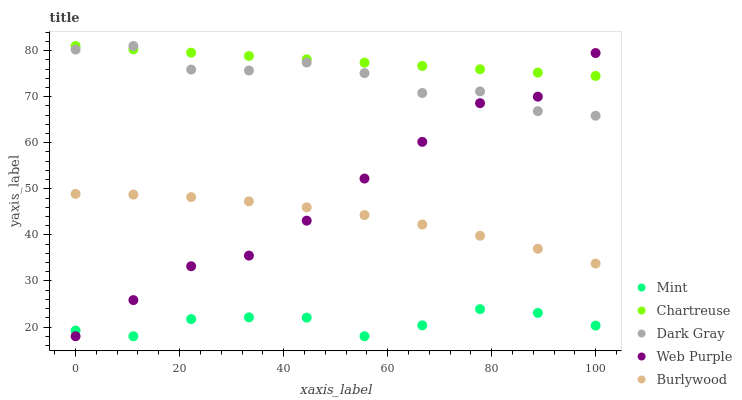Does Mint have the minimum area under the curve?
Answer yes or no. Yes. Does Chartreuse have the maximum area under the curve?
Answer yes or no. Yes. Does Burlywood have the minimum area under the curve?
Answer yes or no. No. Does Burlywood have the maximum area under the curve?
Answer yes or no. No. Is Chartreuse the smoothest?
Answer yes or no. Yes. Is Dark Gray the roughest?
Answer yes or no. Yes. Is Burlywood the smoothest?
Answer yes or no. No. Is Burlywood the roughest?
Answer yes or no. No. Does Mint have the lowest value?
Answer yes or no. Yes. Does Burlywood have the lowest value?
Answer yes or no. No. Does Chartreuse have the highest value?
Answer yes or no. Yes. Does Burlywood have the highest value?
Answer yes or no. No. Is Burlywood less than Dark Gray?
Answer yes or no. Yes. Is Dark Gray greater than Burlywood?
Answer yes or no. Yes. Does Web Purple intersect Dark Gray?
Answer yes or no. Yes. Is Web Purple less than Dark Gray?
Answer yes or no. No. Is Web Purple greater than Dark Gray?
Answer yes or no. No. Does Burlywood intersect Dark Gray?
Answer yes or no. No. 